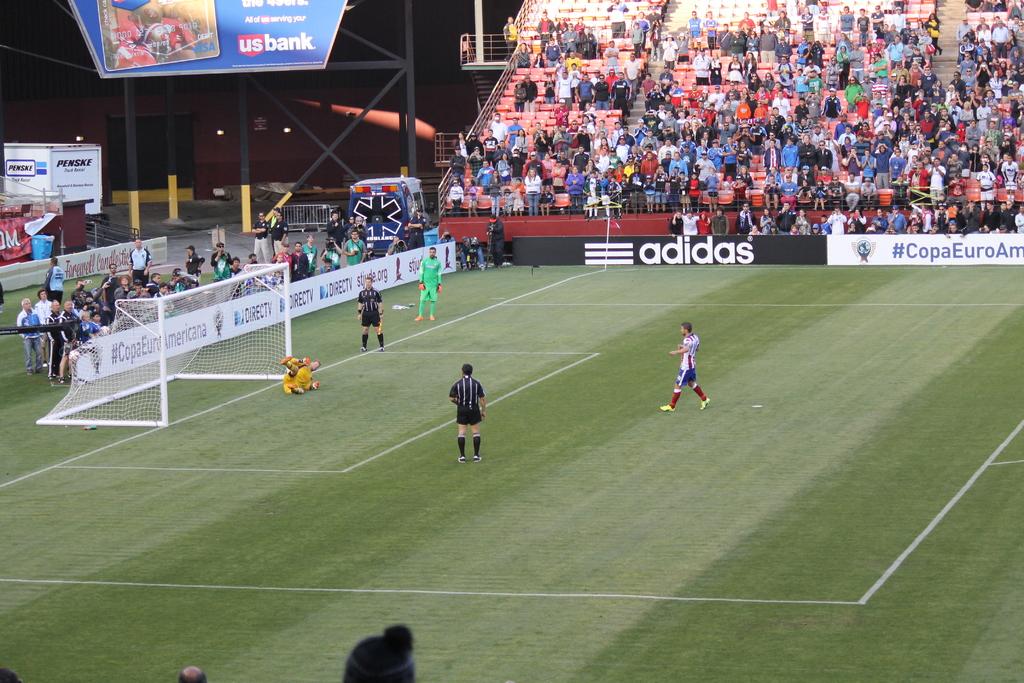What is one brand being advertised?
Your answer should be very brief. Adidas. What bank is on the blue sign?
Offer a terse response. Us bank. 